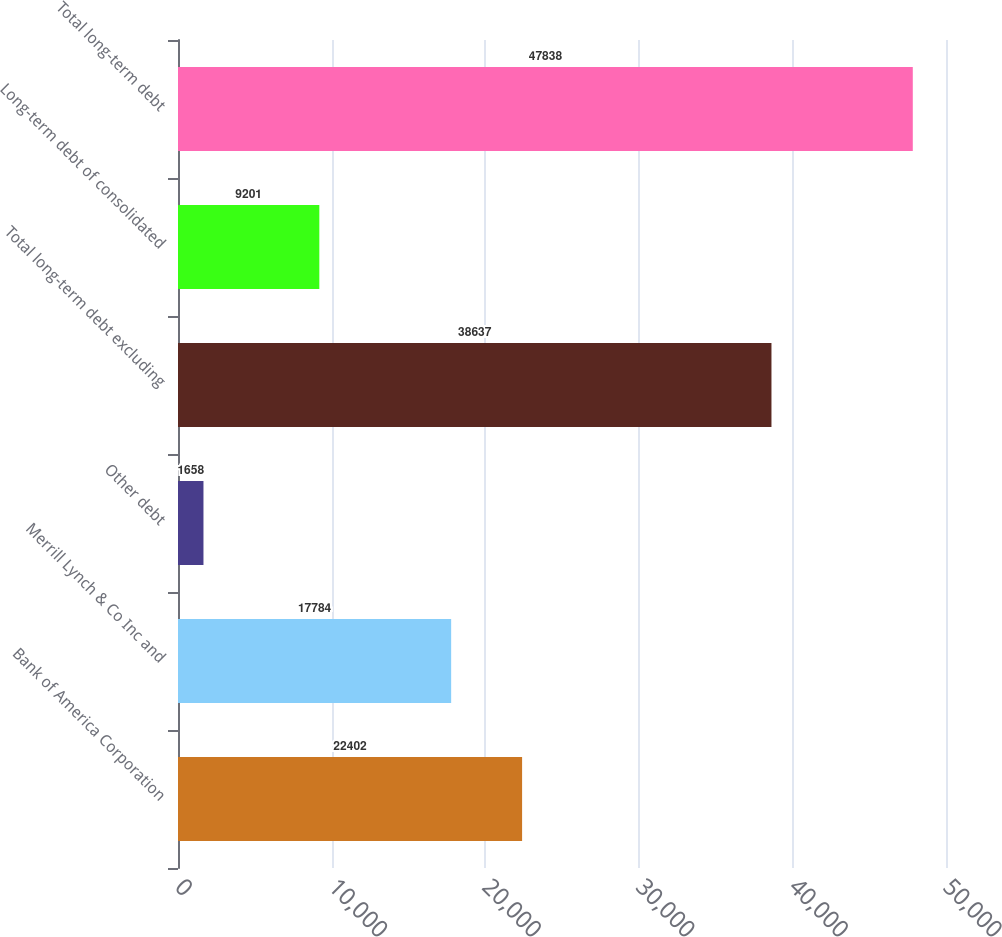Convert chart. <chart><loc_0><loc_0><loc_500><loc_500><bar_chart><fcel>Bank of America Corporation<fcel>Merrill Lynch & Co Inc and<fcel>Other debt<fcel>Total long-term debt excluding<fcel>Long-term debt of consolidated<fcel>Total long-term debt<nl><fcel>22402<fcel>17784<fcel>1658<fcel>38637<fcel>9201<fcel>47838<nl></chart> 